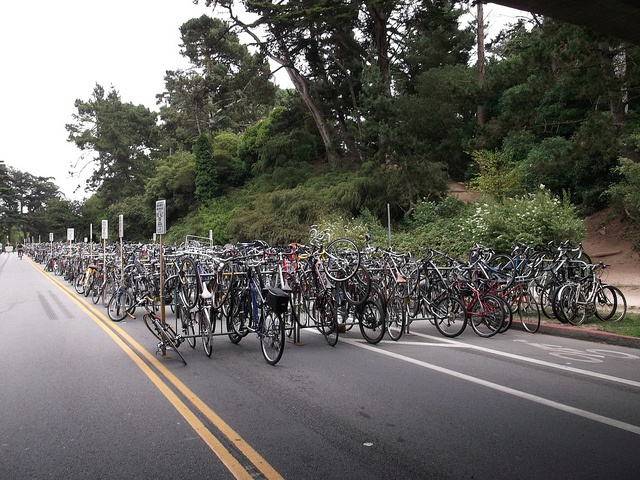Describe the objects in this image and their specific colors. I can see bicycle in white, black, gray, darkgray, and lightgray tones, bicycle in white, black, gray, darkgray, and maroon tones, bicycle in white, black, gray, darkgray, and navy tones, bicycle in white, black, gray, darkgray, and lightgray tones, and bicycle in white, black, gray, darkgray, and lightgray tones in this image. 